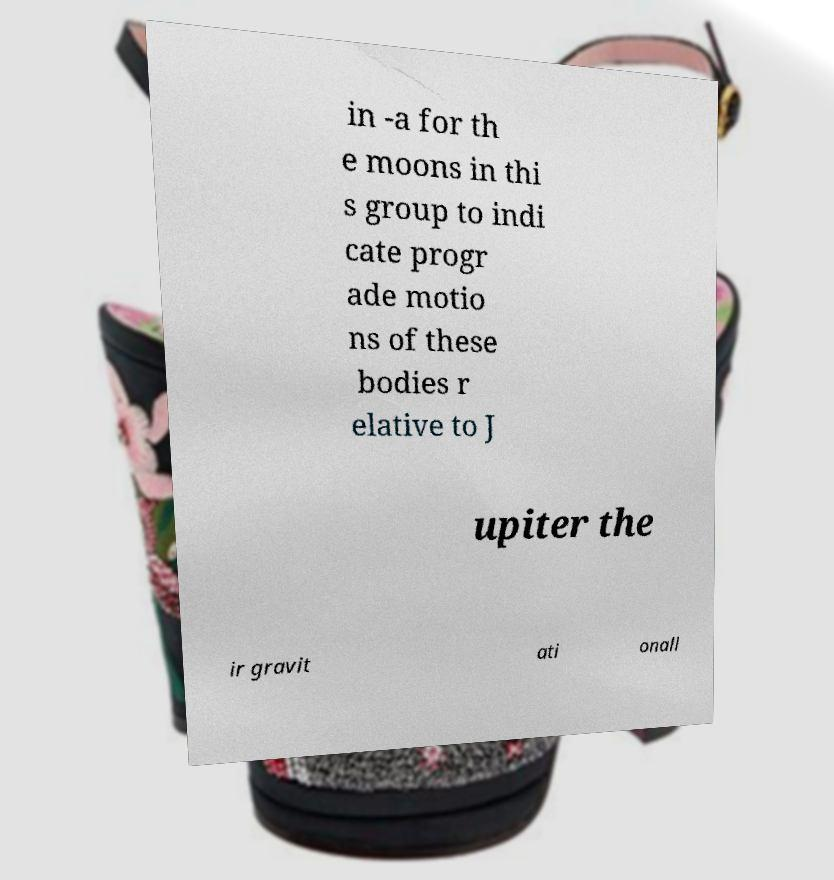What messages or text are displayed in this image? I need them in a readable, typed format. in -a for th e moons in thi s group to indi cate progr ade motio ns of these bodies r elative to J upiter the ir gravit ati onall 